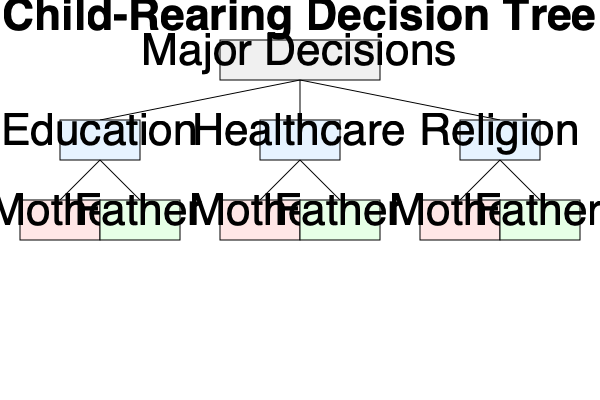Based on the decision tree diagram, which parent has been allocated decision-making authority for the child's healthcare, and how would you modify the tree to reflect joint decision-making for this aspect? To answer this question, let's analyze the decision tree diagram step-by-step:

1. The tree shows three main categories of major decisions: Education, Healthcare, and Religion.

2. Under each category, there are two options: Mother and Father, representing which parent has decision-making authority.

3. For the Healthcare category:
   a. There are two branches: one leading to "Mother" and one leading to "Father".
   b. Both options are present, but neither is specifically highlighted or marked as the chosen option.

4. To determine which parent has been allocated healthcare decision-making authority, we need to look for any visual cues or markings. In this case, there are none, suggesting that the decision has not been made or that the diagram is incomplete.

5. To modify the tree to reflect joint decision-making for healthcare:
   a. We would need to add a new option under the Healthcare category.
   b. This new option could be labeled "Joint" or "Both Parents".
   c. Visually, this could be represented by a new rectangle containing both parents' names or a symbol representing collaboration.

6. The modified healthcare branch would then have three options: Mother, Father, and Joint/Both Parents.

7. To emphasize the joint decision-making, the "Joint/Both Parents" option could be highlighted or marked in some way to indicate it as the chosen path.
Answer: Neither parent is explicitly allocated healthcare decision-making authority. To reflect joint decision-making, add a "Joint/Both Parents" option under the Healthcare category. 